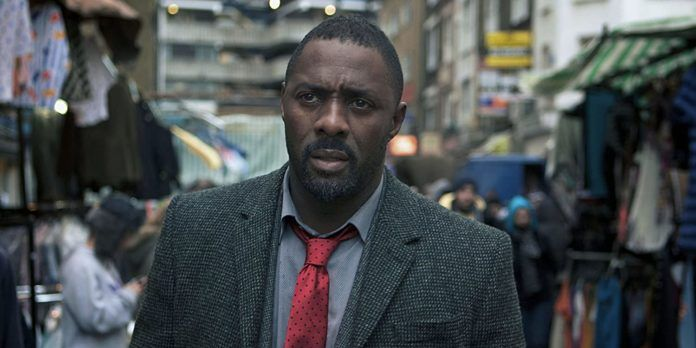Can you elaborate on the elements of the picture provided? This image captures a gripping moment in what appears to be a busy street market. At the center of the image is actor Idris Elba, who is playing the role of DCI John Luther from the BBC series 'Luther.' Dressed in a grey tweed jacket and a striking red tie, Elba’s character exudes a sense of determination and intensity. His focus seems to be directed off to the side, possibly hinting at the complexity and urgency of the situations he confronts. The background is dynamic, filled with market stalls draped in vibrant fabrics and bustling shoppers, adding a rich layer of everyday life that contrasts with the solemnity of his demeanor. This snapshot freezes a moment of high tension, suggesting the character’s deep immersion in his investigative role. 